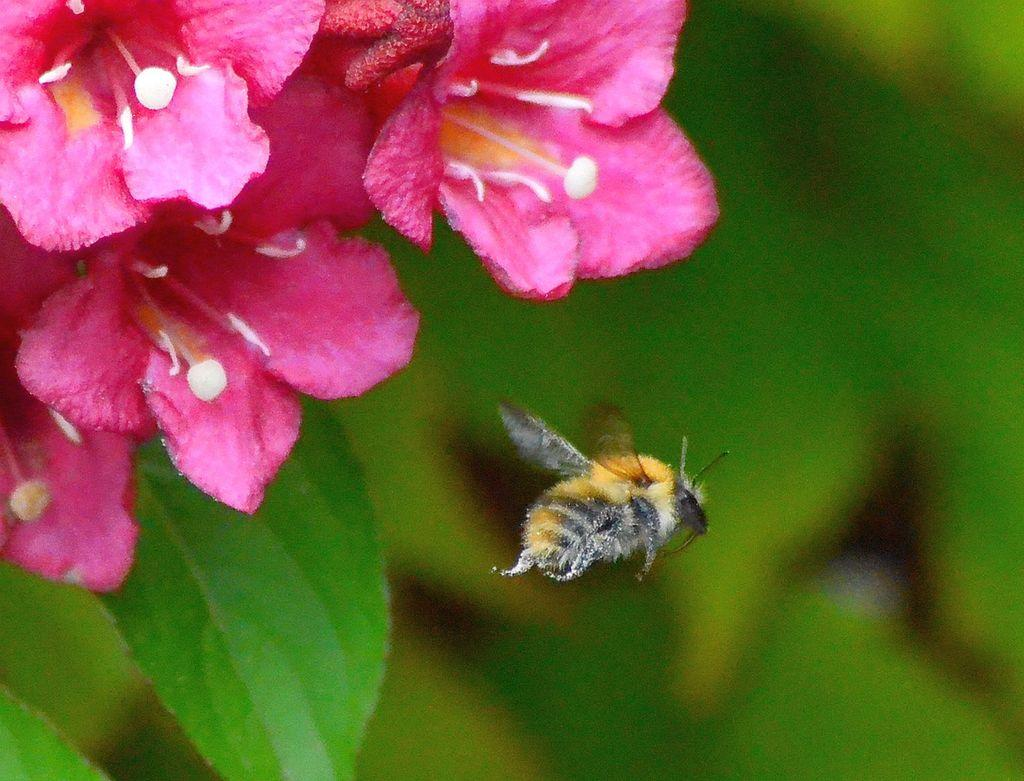What is located in the foreground of the image? There are flowers and a bee in the foreground of the image. Can you describe the flowers in the image? Unfortunately, the facts provided do not give specific details about the flowers. What is the condition of the background in the image? The background of the image is blurry. Is there a tub filled with milk in the background of the image? There is no tub or milk present in the image. 